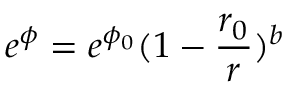Convert formula to latex. <formula><loc_0><loc_0><loc_500><loc_500>e ^ { \phi } = e ^ { \phi _ { 0 } } ( 1 - \frac { r _ { 0 } } { r } ) ^ { b }</formula> 